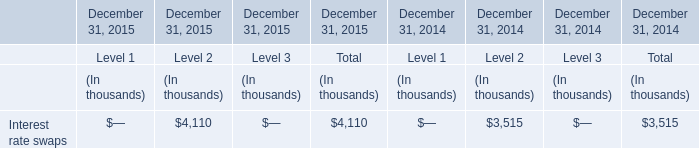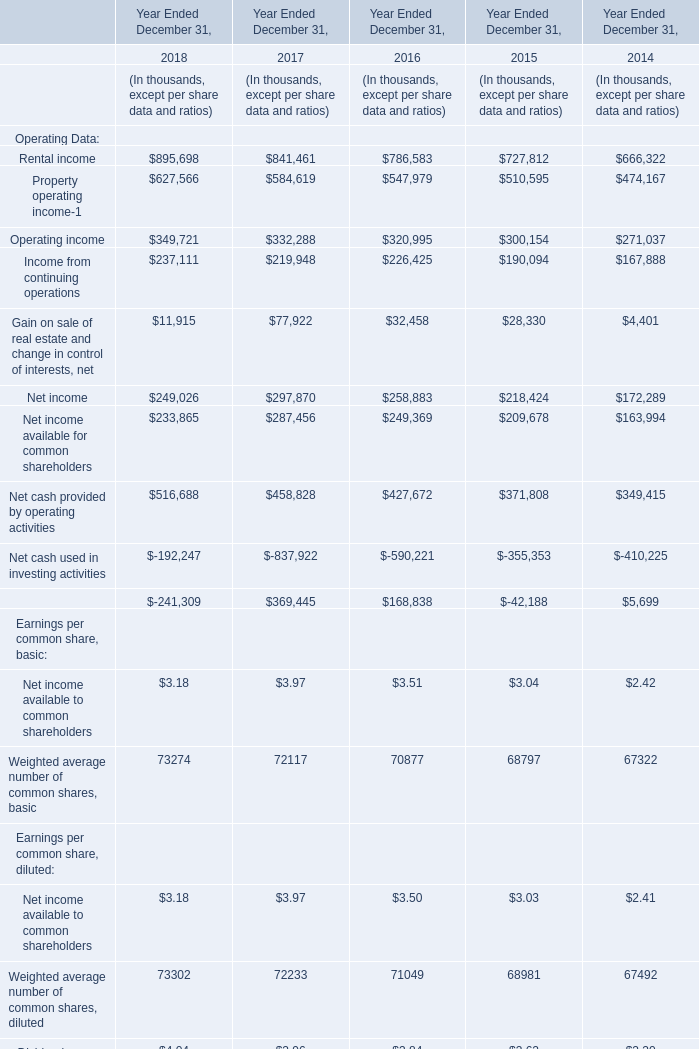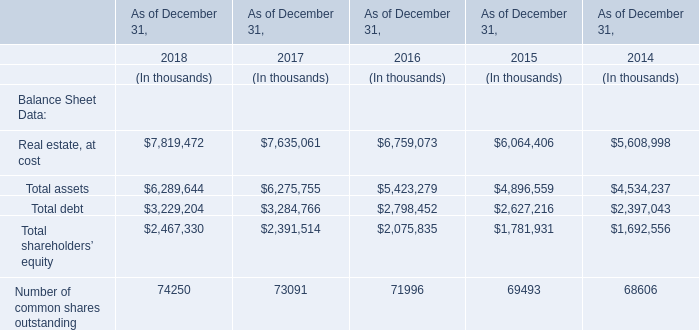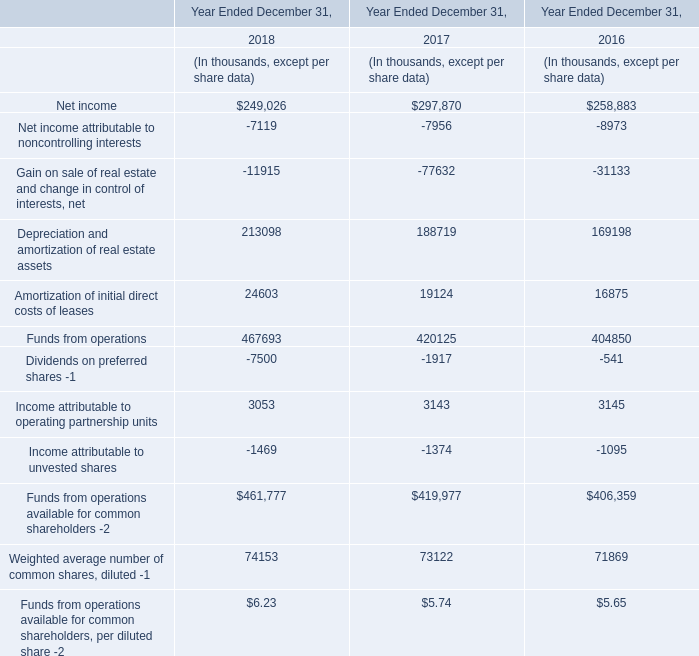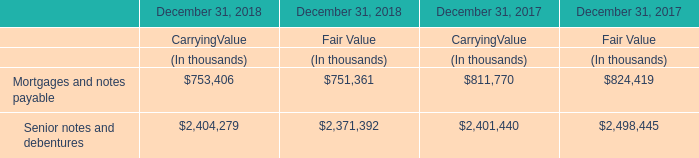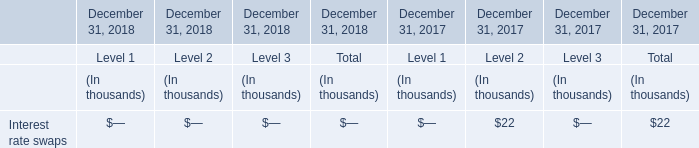What was the average of operating income in 2016, 2017, and 2018 ? (in thousand) 
Computations: (((349721 + 332288) + 320995) / 3)
Answer: 334334.66667. 